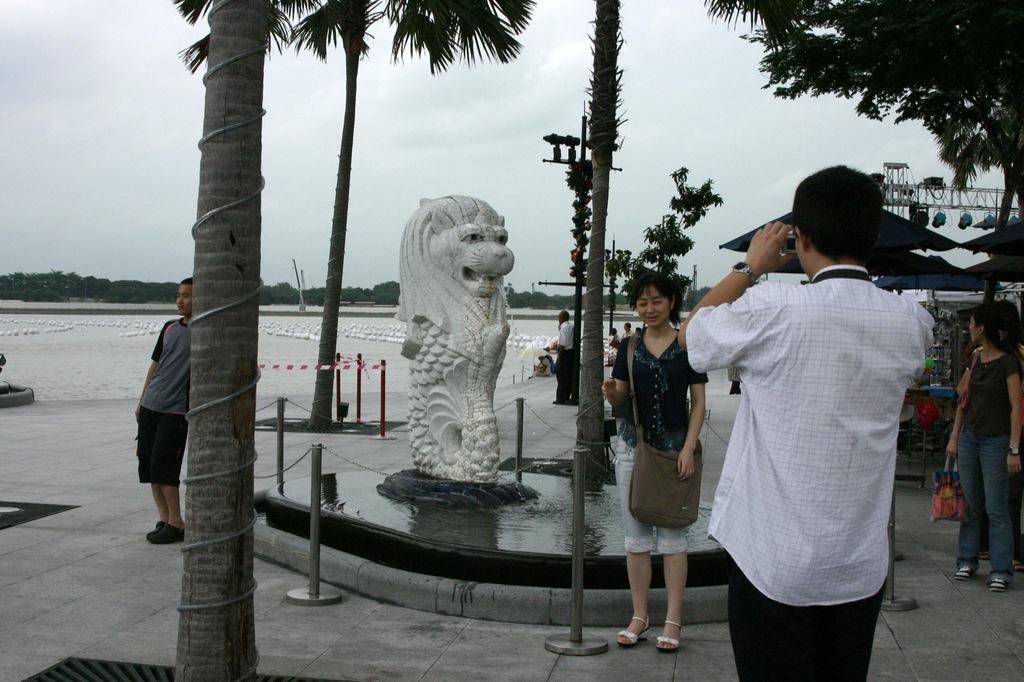How would you summarize this image in a sentence or two? In this image we can see a few people, among them some are holding the objects, there are some trees, poles, huts, fence, bridge and a sculpture, in the background we can see the sky. 